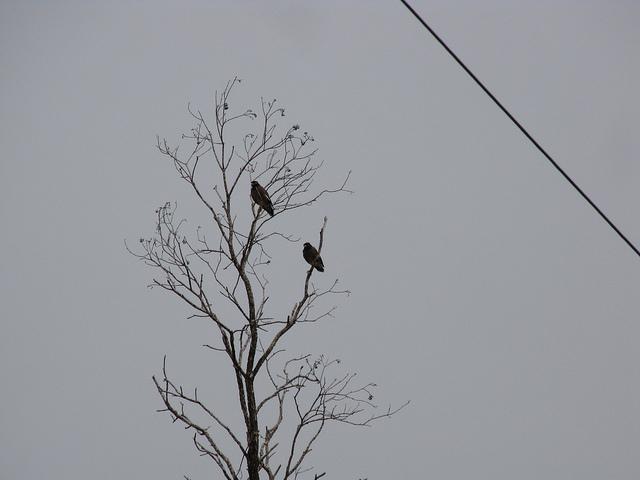Is it winter?
Keep it brief. Yes. Are those penguins?
Quick response, please. No. What is the bird on?
Keep it brief. Tree. Is it sunny?
Write a very short answer. No. Is the bird a predator?
Be succinct. No. What are the birds sitting on?
Give a very brief answer. Tree. What are the birds perched on?
Give a very brief answer. Tree. How many birds are there?
Quick response, please. 2. Are there several birds on the wire?
Quick response, please. No. How many birds?
Concise answer only. 2. What is the bird resting on?
Give a very brief answer. Branch. Are all the birds sitting?
Concise answer only. Yes. How many wires are there?
Concise answer only. 1. What is the bird sitting on?
Give a very brief answer. Branch. 